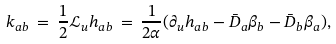<formula> <loc_0><loc_0><loc_500><loc_500>k _ { a b } \, = \, \frac { 1 } { 2 } \mathcal { L } _ { u } h _ { a b } \, = \, \frac { 1 } { 2 \alpha } ( \partial _ { u } h _ { a b } - \bar { D } _ { a } \beta _ { b } - \bar { D } _ { b } \beta _ { a } ) ,</formula> 